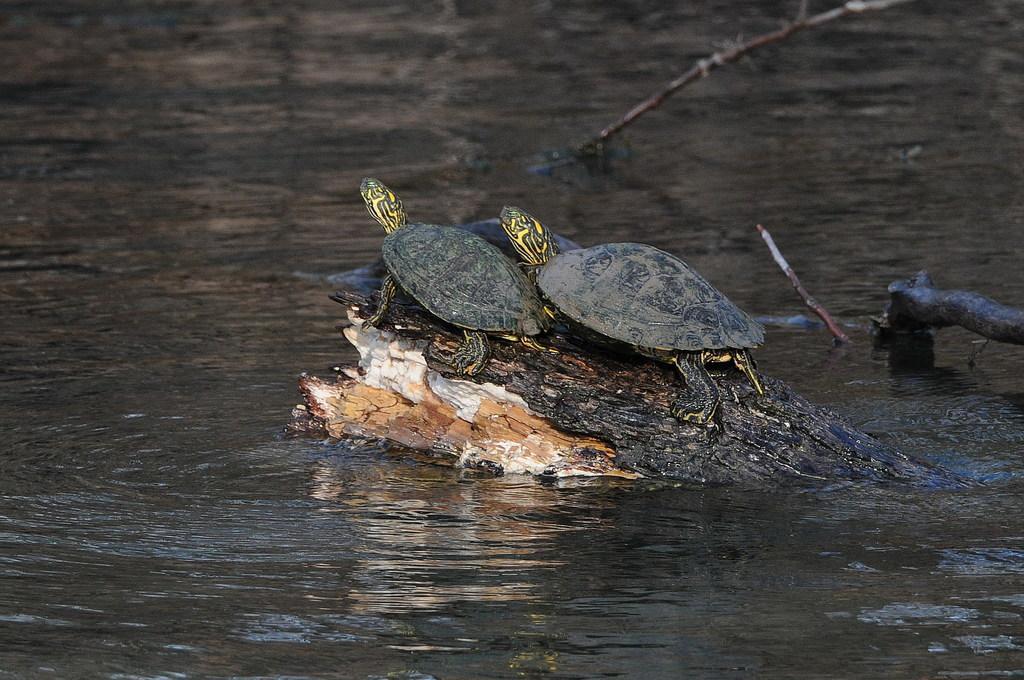Can you describe this image briefly? In this picture there are two tortoises on a broken tree trunk which is on the water and there are some other objects in the background. 